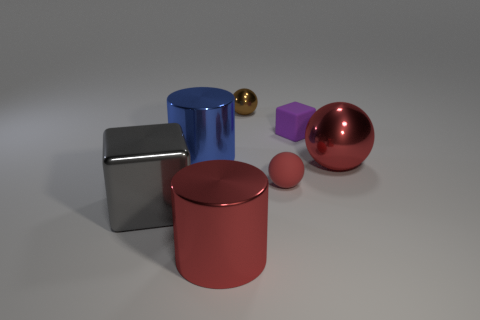Add 2 yellow spheres. How many objects exist? 9 Subtract all blocks. How many objects are left? 5 Add 4 small brown spheres. How many small brown spheres exist? 5 Subtract 0 green cylinders. How many objects are left? 7 Subtract all tiny yellow matte spheres. Subtract all large red cylinders. How many objects are left? 6 Add 1 tiny purple cubes. How many tiny purple cubes are left? 2 